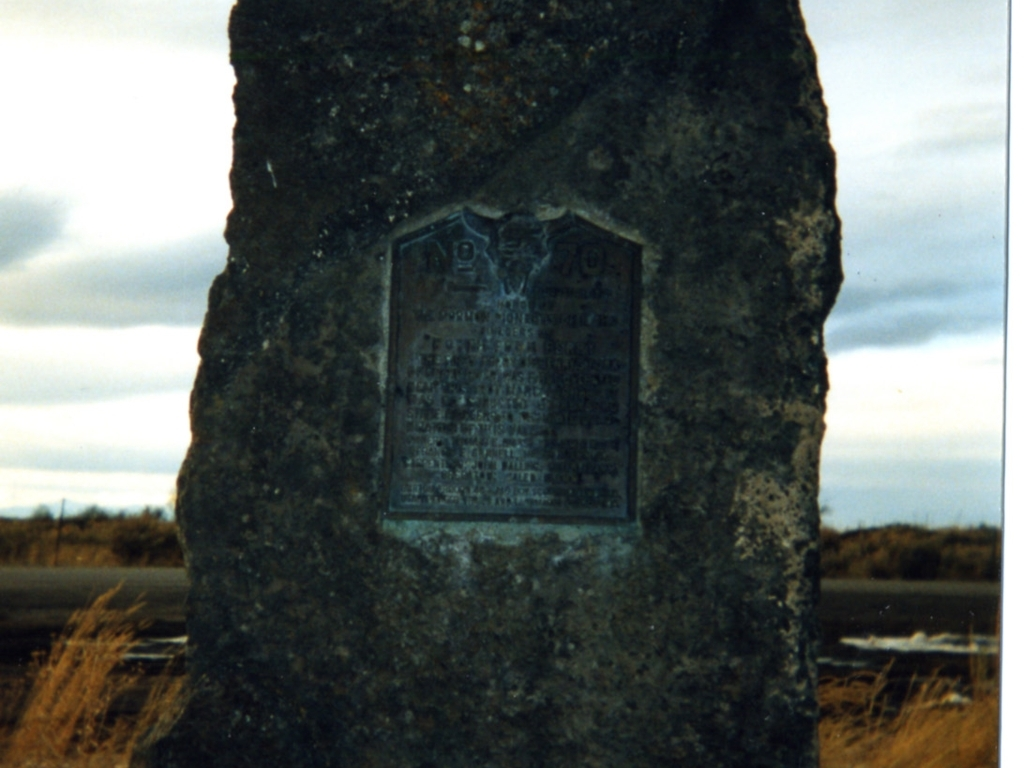How might the setting influence the interpretation of this image? The setting of the monument, in what appears to be a barren or sparsely vegetated landscape, may evoke a sense of isolation or remembrance in a place that has remained unchanged for a long time. It might imply that the event or person commemorated here had a lasting impact on the area, which still stands as a solitary reminder of the past amidst the landscape. 